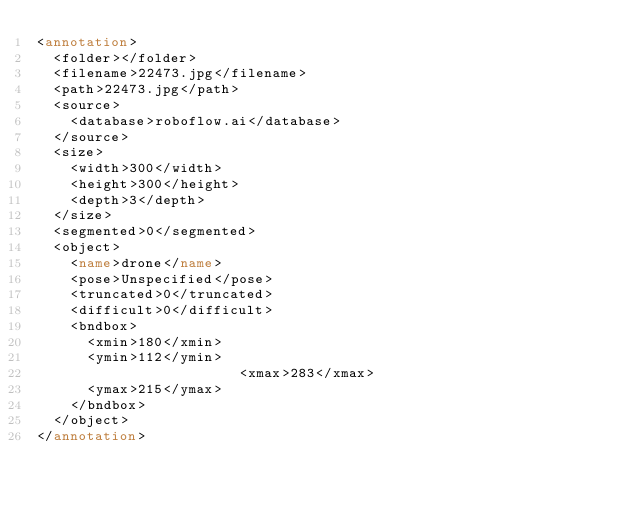<code> <loc_0><loc_0><loc_500><loc_500><_XML_><annotation>
	<folder></folder>
	<filename>22473.jpg</filename>
	<path>22473.jpg</path>
	<source>
		<database>roboflow.ai</database>
	</source>
	<size>
		<width>300</width>
		<height>300</height>
		<depth>3</depth>
	</size>
	<segmented>0</segmented>
	<object>
		<name>drone</name>
		<pose>Unspecified</pose>
		<truncated>0</truncated>
		<difficult>0</difficult>
		<bndbox>
			<xmin>180</xmin>
			<ymin>112</ymin>
                        <xmax>283</xmax>
			<ymax>215</ymax>
		</bndbox>
	</object>
</annotation>
</code> 